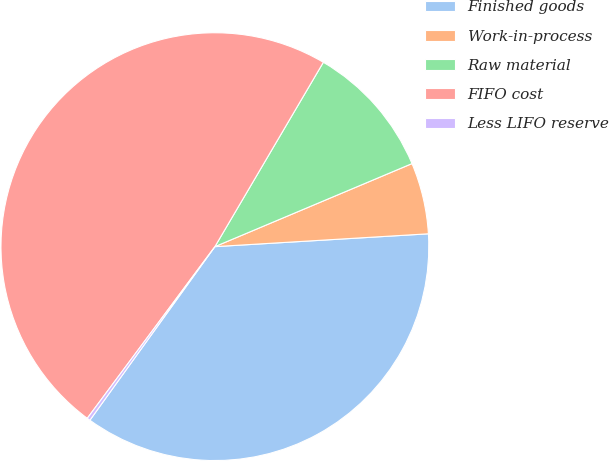Convert chart to OTSL. <chart><loc_0><loc_0><loc_500><loc_500><pie_chart><fcel>Finished goods<fcel>Work-in-process<fcel>Raw material<fcel>FIFO cost<fcel>Less LIFO reserve<nl><fcel>35.89%<fcel>5.39%<fcel>10.19%<fcel>48.29%<fcel>0.24%<nl></chart> 